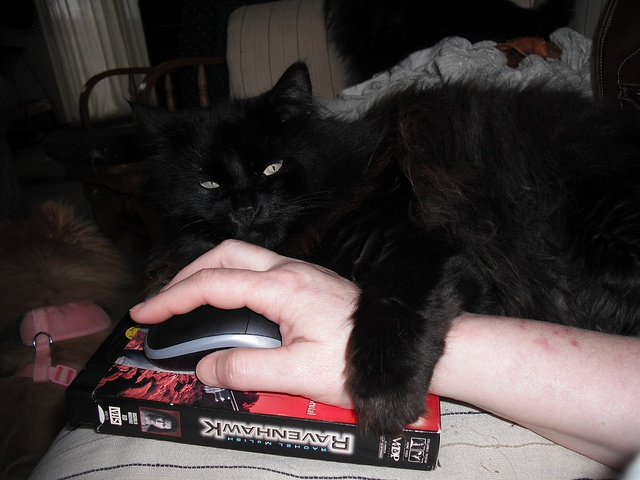Describe the objects in this image and their specific colors. I can see cat in black, gray, and darkgray tones, people in black, lightgray, pink, darkgray, and gray tones, book in black, gray, maroon, and darkgray tones, mouse in black, darkgray, gray, and lightgray tones, and handbag in black, maroon, and brown tones in this image. 